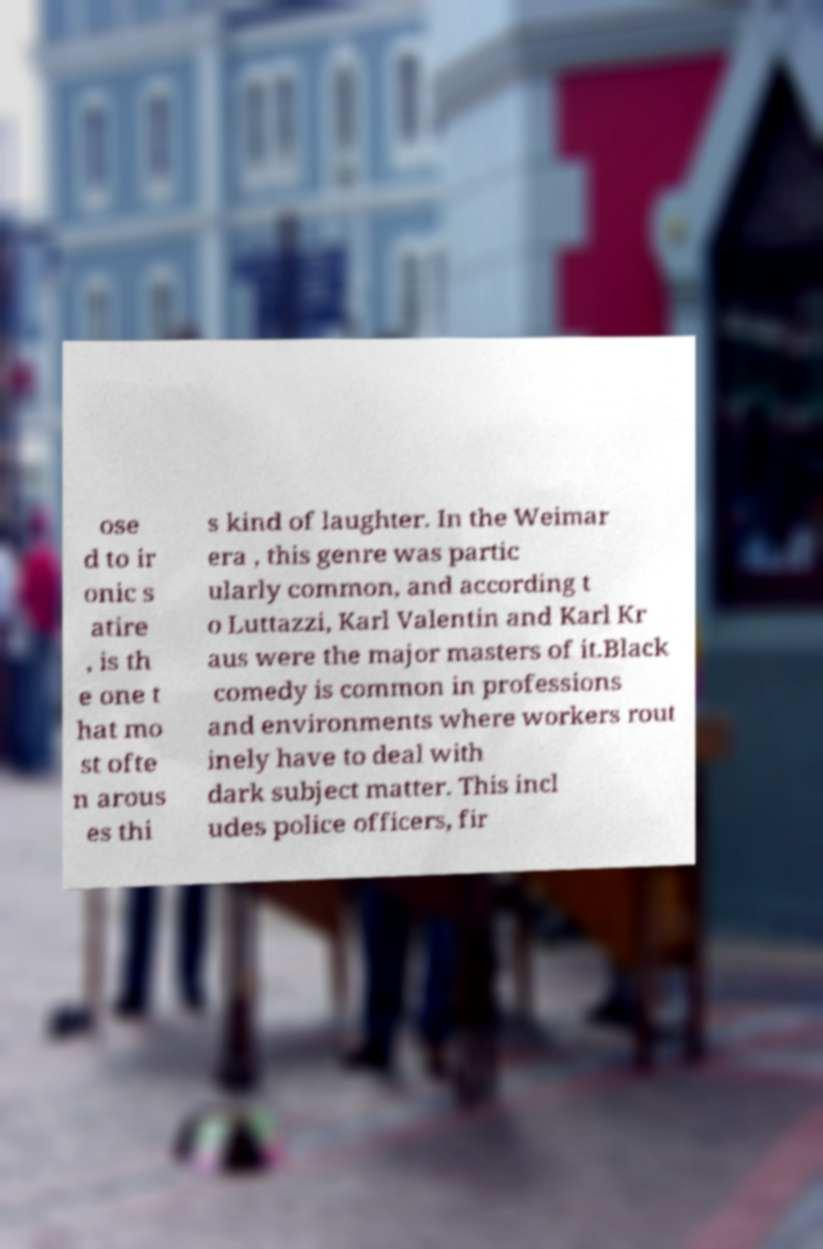Can you accurately transcribe the text from the provided image for me? ose d to ir onic s atire , is th e one t hat mo st ofte n arous es thi s kind of laughter. In the Weimar era , this genre was partic ularly common, and according t o Luttazzi, Karl Valentin and Karl Kr aus were the major masters of it.Black comedy is common in professions and environments where workers rout inely have to deal with dark subject matter. This incl udes police officers, fir 